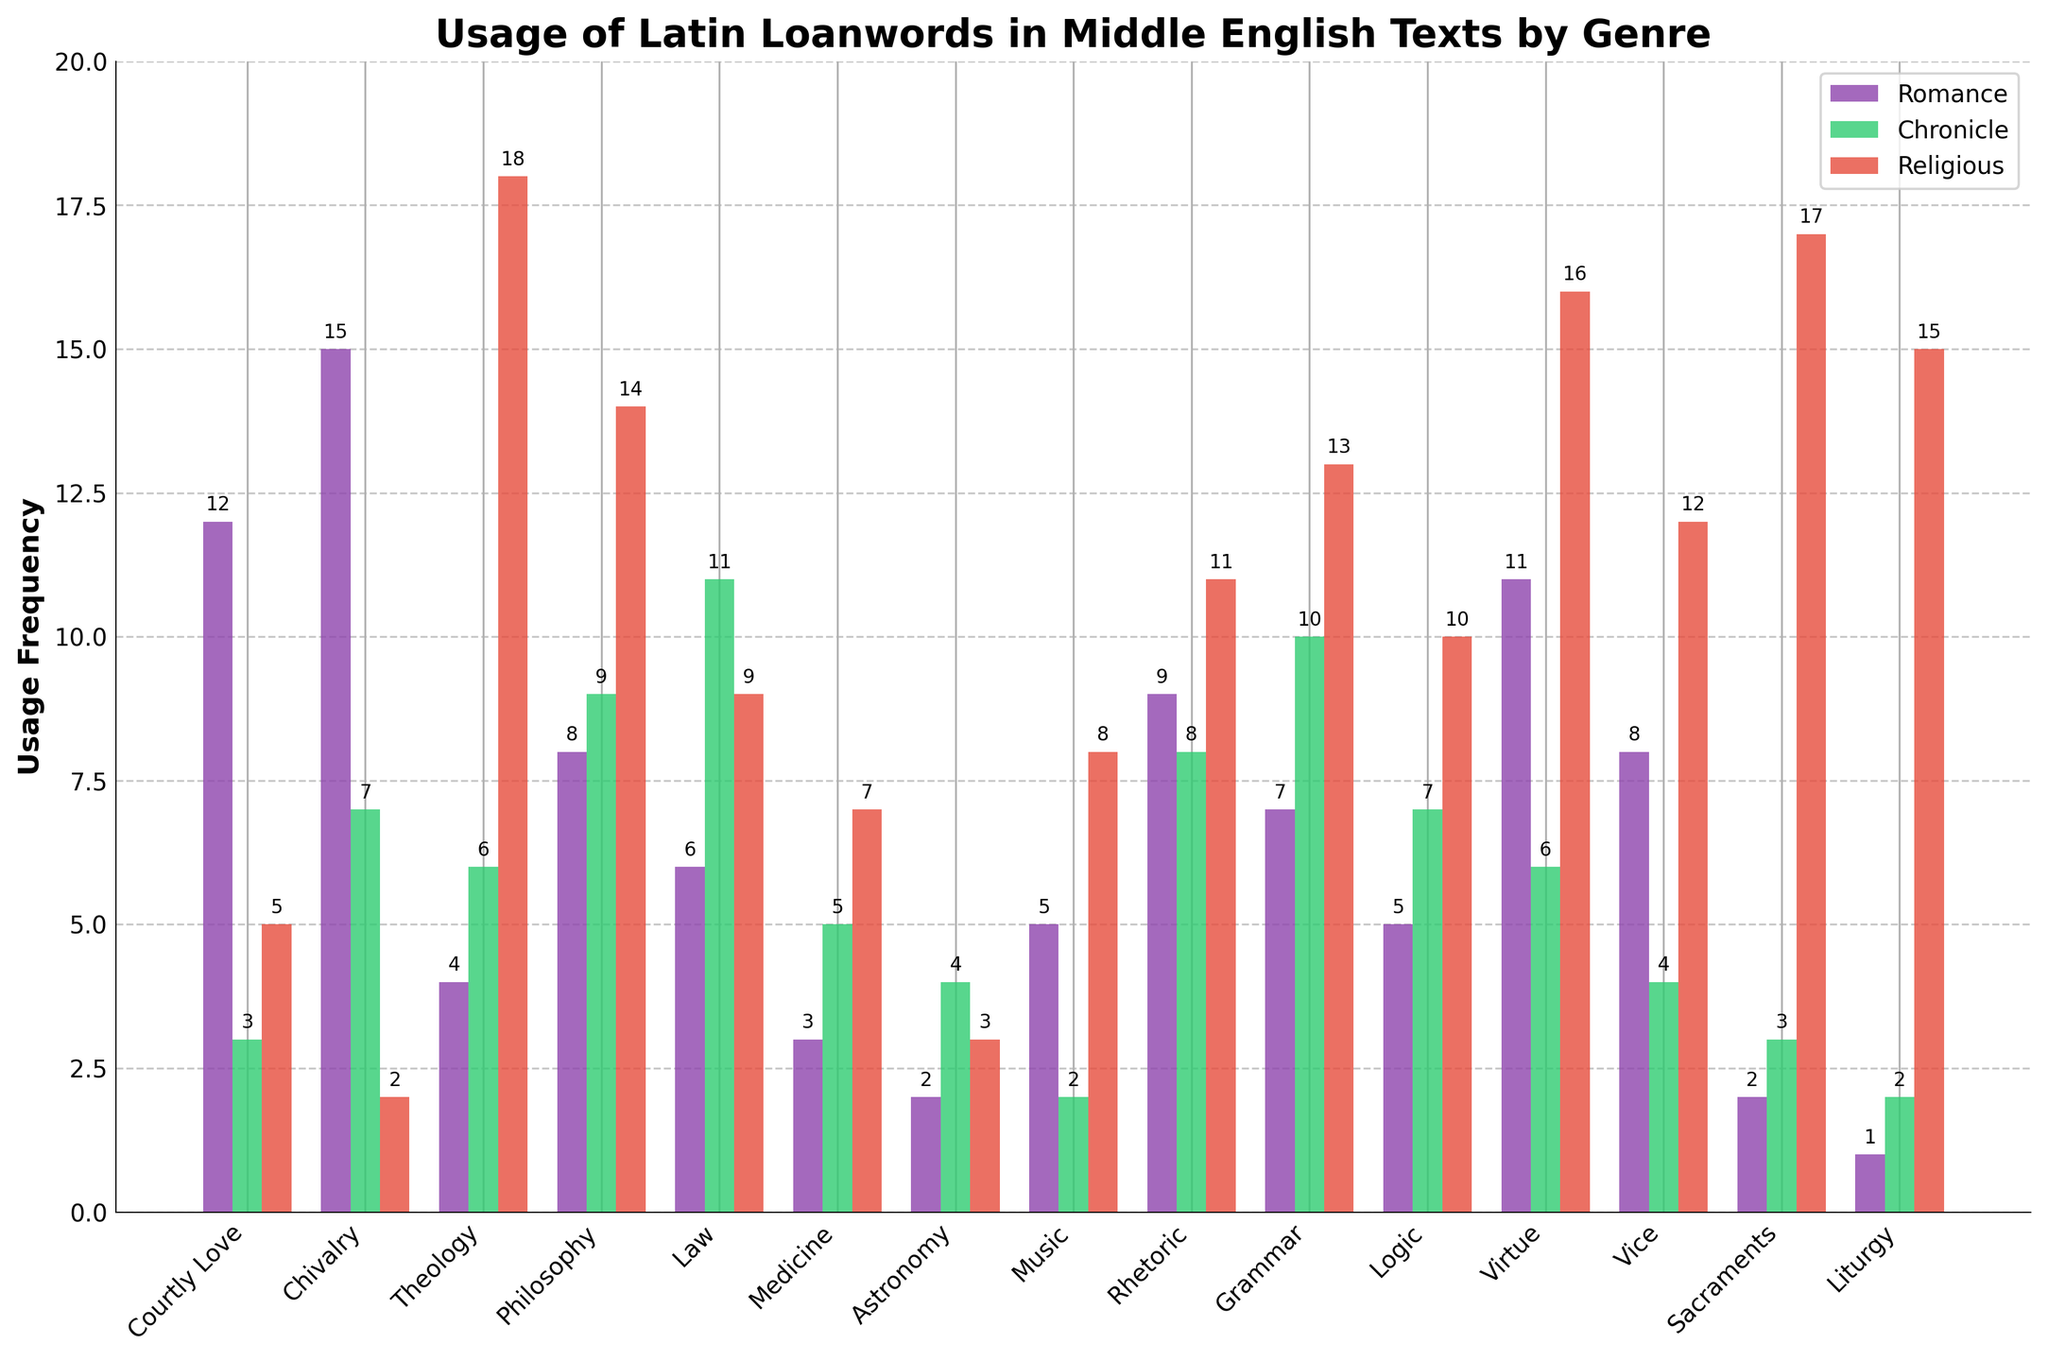What genre has the highest usage of Latin loanwords in the 'Romance' category? By looking at the height of the bars in the 'Romance' category, the 'Chivalry' genre has the tallest bar.
Answer: Chivalry Which genre has the lowest usage of Latin loanwords in the 'Religious' category? By comparing the heights of the bars in the 'Religious' category, 'Courtly Love' is the shortest.
Answer: Courtly Love What is the total usage frequency of Latin loanwords in the 'Chronicle' category for 'Theology' and 'Philosophy' genres? By adding the heights of the bars for 'Theology' (6) and 'Philosophy' (9) in the 'Chronicle' category, the total is 6 + 9 = 15.
Answer: 15 Which genre shows a consistent usage frequency of Latin loanwords across all three categories? 'Vice' shows different usages in 'Romance' (8), 'Chronicle' (4), and 'Religious' (12), so another genre must be examined. None of the genres show the same frequency across all categories.
Answer: None What is the average usage of Latin loanwords in the 'Religious' category across all genres? By summing all the values in the 'Religious' category and dividing by the total number of genres (15), the calculation is (5 + 2 + 18 + 14 + 9 + 7 + 3 + 8 + 11 + 13 + 10 + 16 + 12 + 17 + 15) / 15 = 160 / 15 ≈ 10.67.
Answer: 10.67 Which genre has more frequent use of Latin loanwords in 'Chronicle' than in 'Romance'? By examining each genre, 'Law' (Romance: 6, Chronicle: 11), 'Philosophy' (Romance: 8, Chronicle: 9), and 'Grammar' (Romance: 7, Chronicle: 10) have higher frequencies in 'Chronicle' than in 'Romance'.
Answer: Law, Philosophy, Grammar How much higher is the frequency of Latin loanwords in the 'Religious' category for 'Sacraments' compared to 'Medicine'? By subtracting the height of the 'Medicine' bar (7) from the 'Sacraments' bar (17), the difference is 17 - 7 = 10.
Answer: 10 Which category has the highest total usage frequency of Latin loanwords for the 'Virtues' genre? By comparing the bars for the 'Virtues' genre in all three categories: 'Romance' (11), 'Chronicle' (6), and 'Religious' (16), 'Religious' has the highest bar.
Answer: Religious What is the difference in Latin loanword usage between 'Romance' and 'Chronicle' categories for the 'Rhetoric' genre? By subtracting the height of the 'Chronicle' bar (8) from the 'Romance' bar (9) for 'Rhetoric', the difference is 9 - 8 = 1.
Answer: 1 What is the combined usage frequency for 'Courtly Love' and 'Chivalry' in the 'Romance' category? By adding the heights of the bars for 'Courtly Love' (12) and 'Chivalry' (15) in the 'Romance' category, the total is 12 + 15 = 27.
Answer: 27 